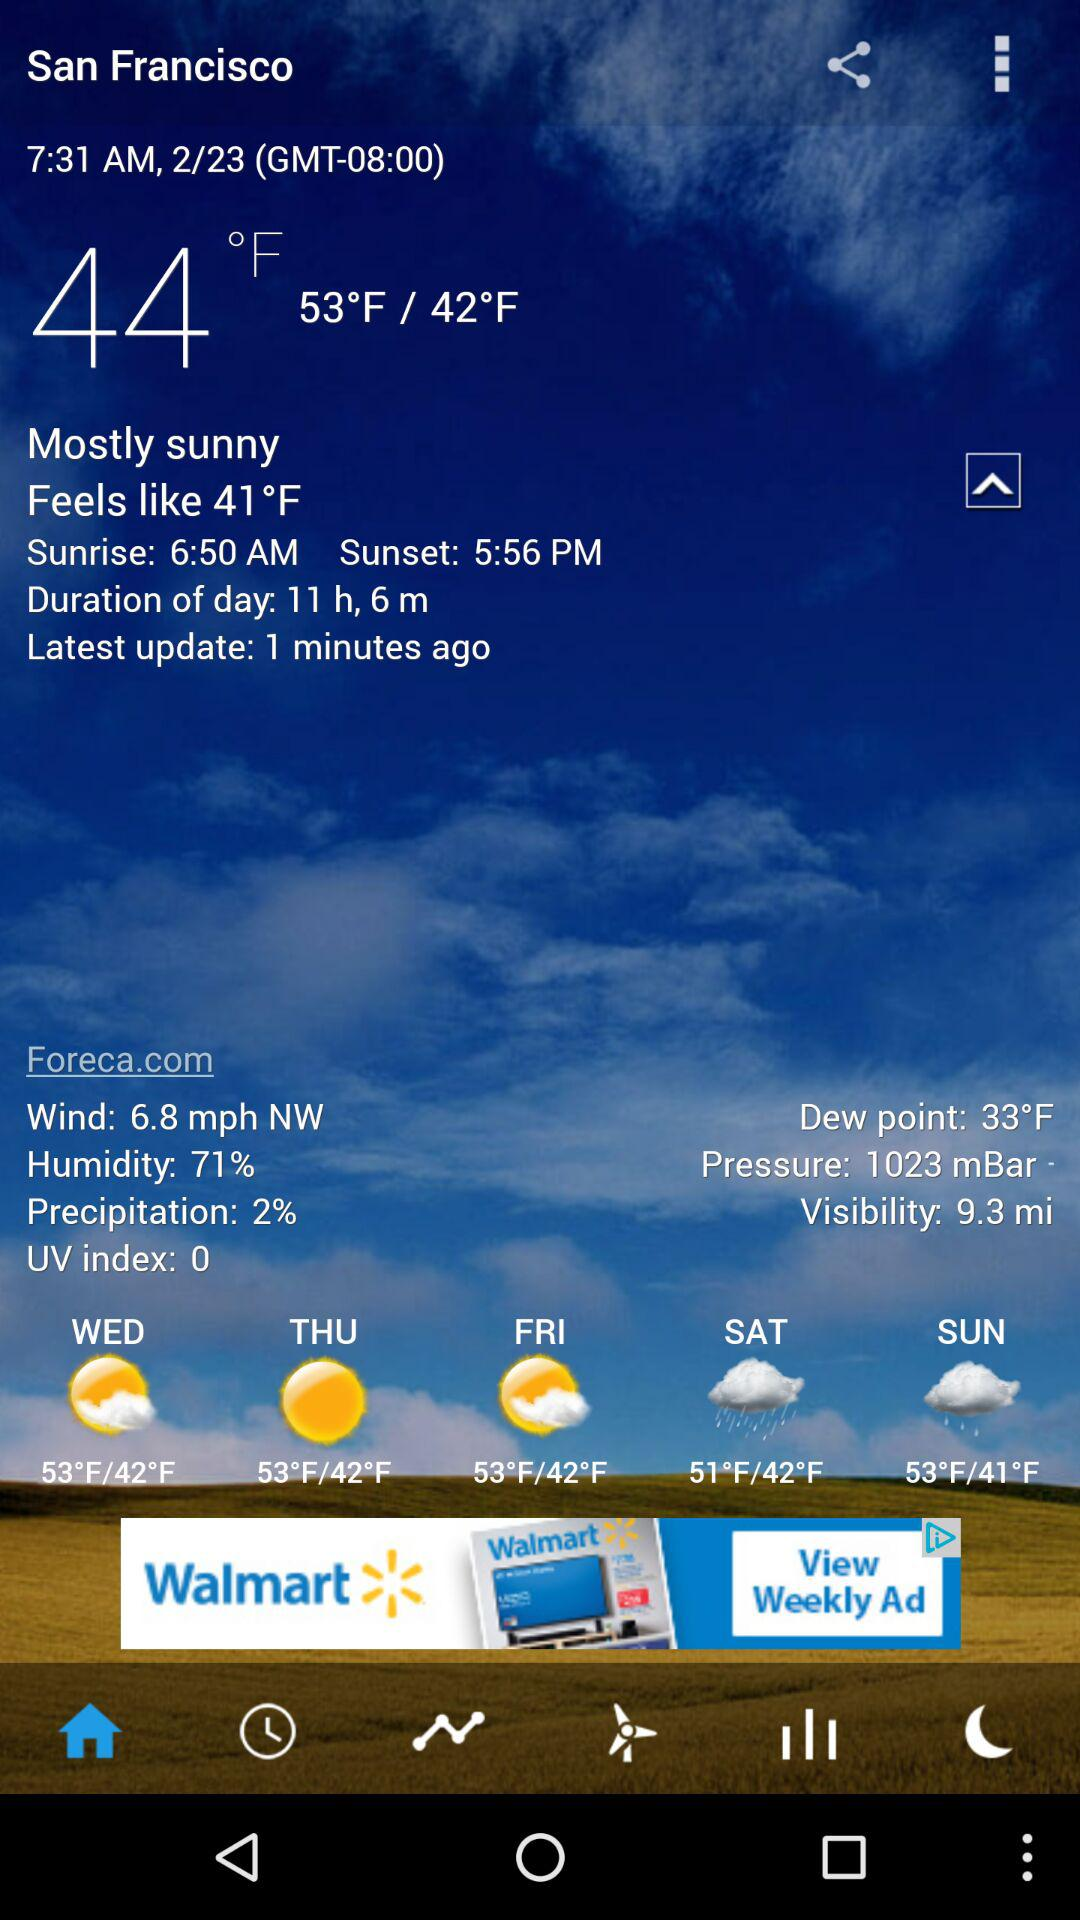What is the location? The location is San Francisco. 